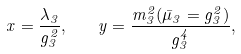<formula> <loc_0><loc_0><loc_500><loc_500>x = \frac { \lambda _ { 3 } } { g _ { 3 } ^ { 2 } } , \quad y = \frac { m _ { 3 } ^ { 2 } ( \bar { \mu } _ { 3 } = g _ { 3 } ^ { 2 } ) } { g _ { 3 } ^ { 4 } } ,</formula> 